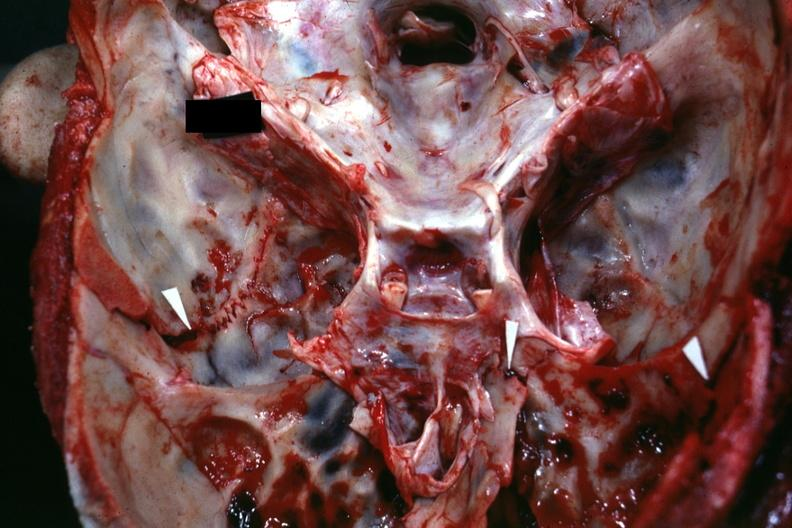s bone, calvarium present?
Answer the question using a single word or phrase. Yes 